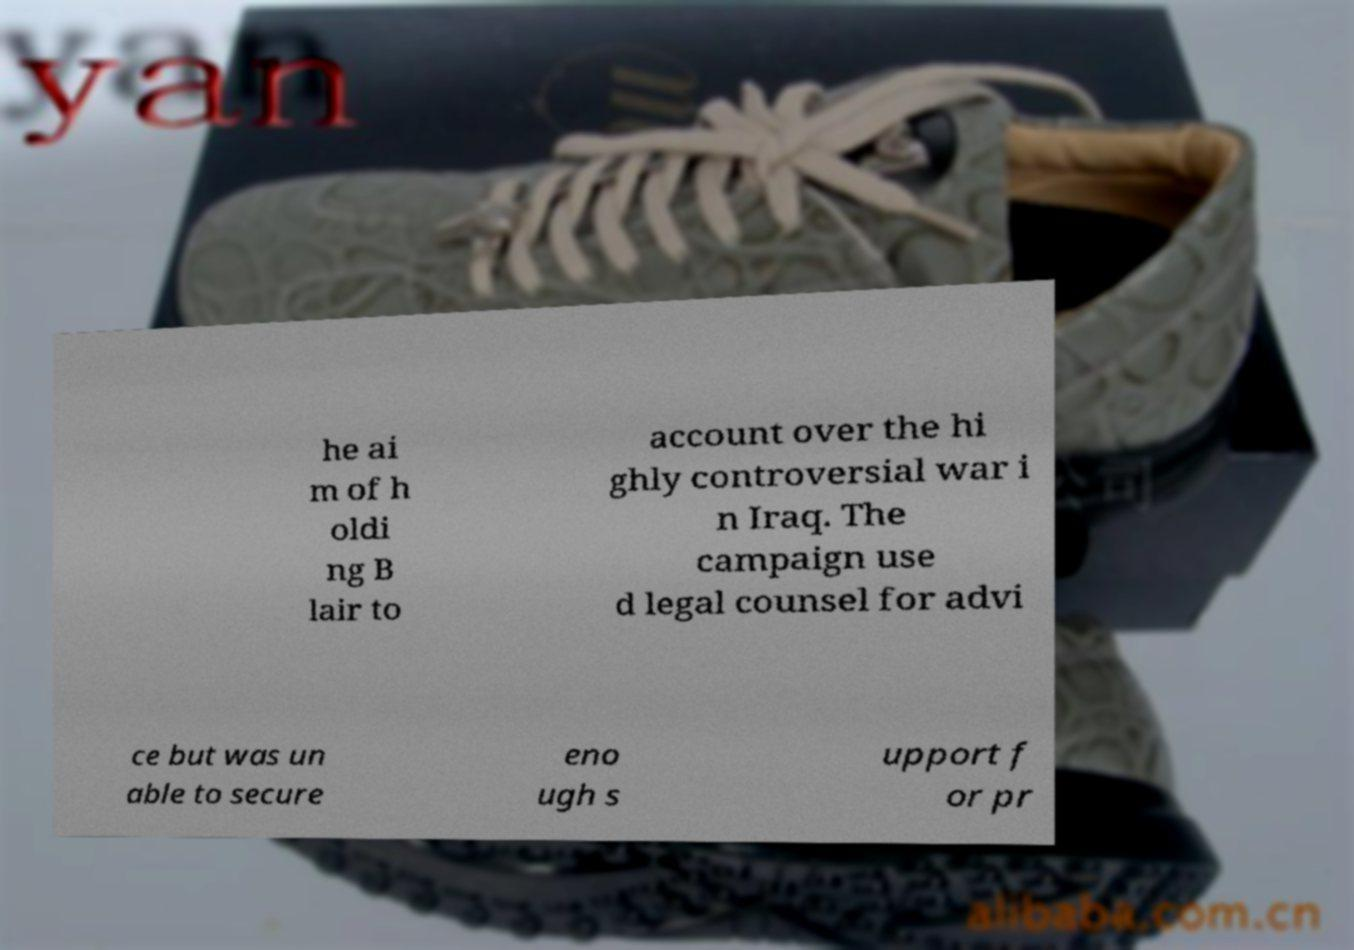Please identify and transcribe the text found in this image. he ai m of h oldi ng B lair to account over the hi ghly controversial war i n Iraq. The campaign use d legal counsel for advi ce but was un able to secure eno ugh s upport f or pr 